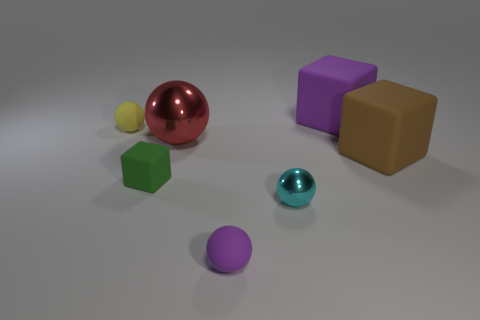Subtract all cyan spheres. How many spheres are left? 3 Subtract all small yellow balls. How many balls are left? 3 Add 3 tiny purple rubber balls. How many objects exist? 10 Subtract all blue balls. Subtract all green blocks. How many balls are left? 4 Subtract all blocks. How many objects are left? 4 Subtract 1 brown blocks. How many objects are left? 6 Subtract all big yellow rubber things. Subtract all small green cubes. How many objects are left? 6 Add 1 large red balls. How many large red balls are left? 2 Add 7 big red metallic balls. How many big red metallic balls exist? 8 